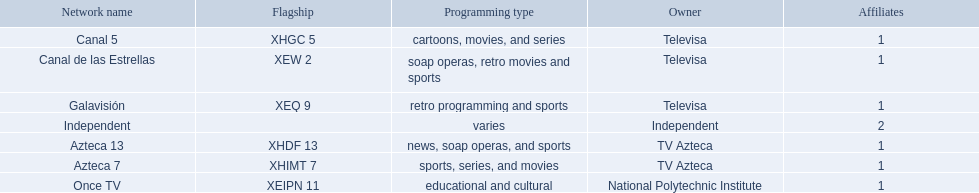Which owner only owns one network? National Polytechnic Institute, Independent. Of those, what is the network name? Once TV, Independent. Of those, which programming type is educational and cultural? Once TV. 